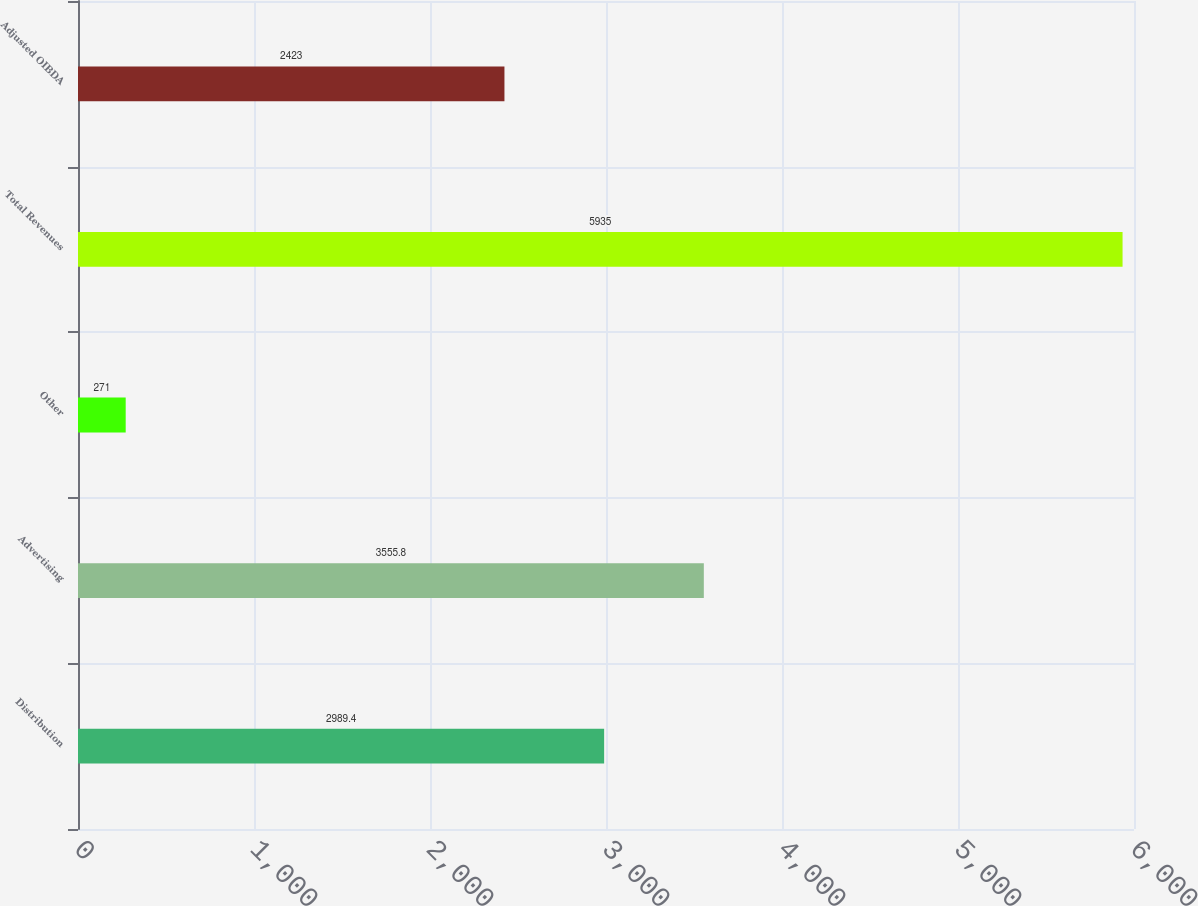Convert chart. <chart><loc_0><loc_0><loc_500><loc_500><bar_chart><fcel>Distribution<fcel>Advertising<fcel>Other<fcel>Total Revenues<fcel>Adjusted OIBDA<nl><fcel>2989.4<fcel>3555.8<fcel>271<fcel>5935<fcel>2423<nl></chart> 